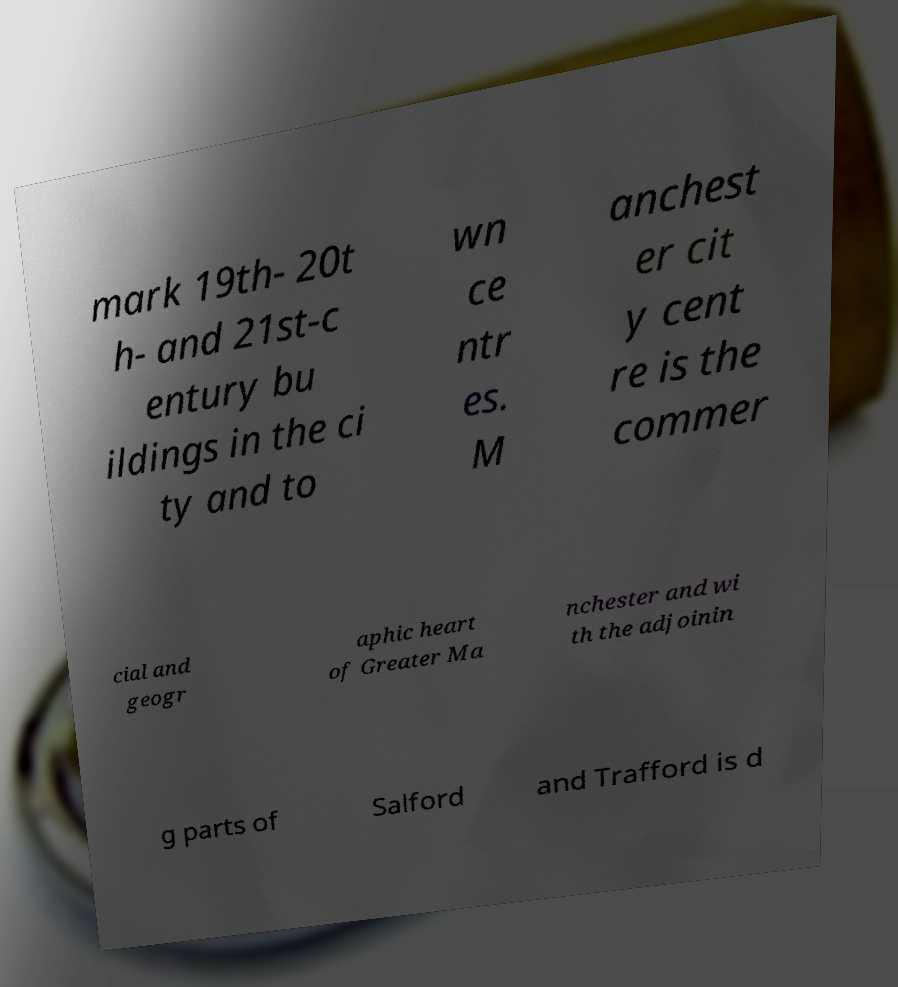I need the written content from this picture converted into text. Can you do that? mark 19th- 20t h- and 21st-c entury bu ildings in the ci ty and to wn ce ntr es. M anchest er cit y cent re is the commer cial and geogr aphic heart of Greater Ma nchester and wi th the adjoinin g parts of Salford and Trafford is d 